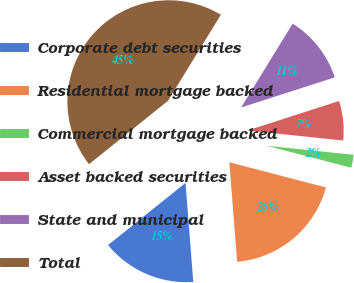Convert chart. <chart><loc_0><loc_0><loc_500><loc_500><pie_chart><fcel>Corporate debt securities<fcel>Residential mortgage backed<fcel>Commercial mortgage backed<fcel>Asset backed securities<fcel>State and municipal<fcel>Total<nl><fcel>15.48%<fcel>19.7%<fcel>2.4%<fcel>6.61%<fcel>11.27%<fcel>44.53%<nl></chart> 